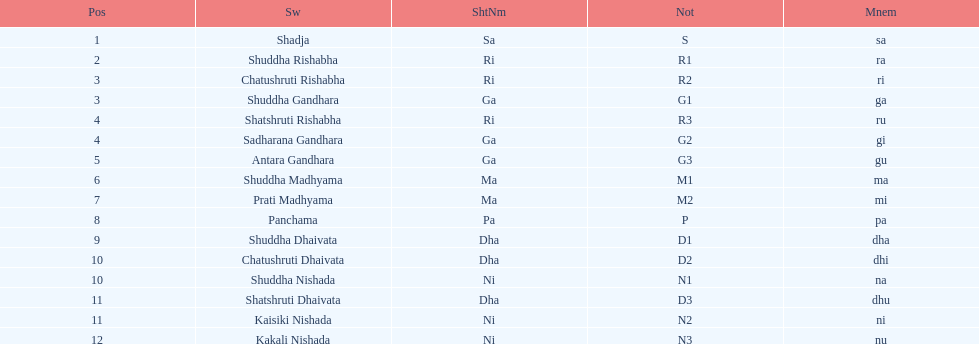Which swara holds the last position? Kakali Nishada. 